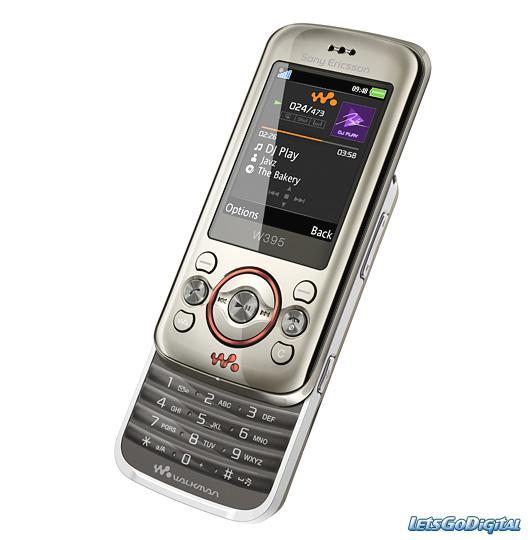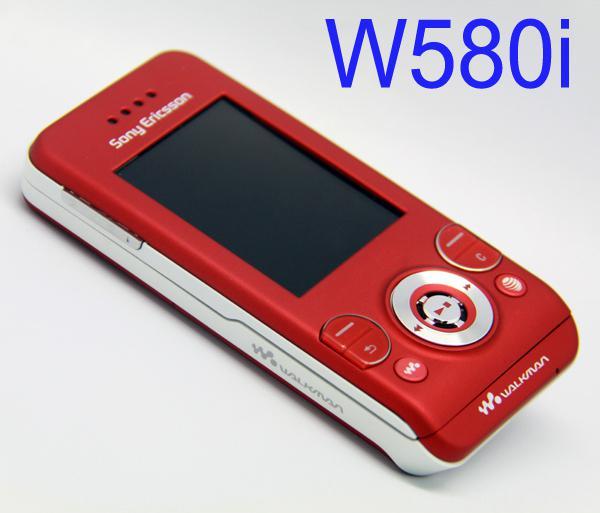The first image is the image on the left, the second image is the image on the right. Considering the images on both sides, is "Each image contains one device, each device has a vertical rectangular screen, and one device is shown with its front sliding up to reveal the key pad." valid? Answer yes or no. Yes. The first image is the image on the left, the second image is the image on the right. Evaluate the accuracy of this statement regarding the images: "The phone in the image on the right is in the slide out position.". Is it true? Answer yes or no. No. 